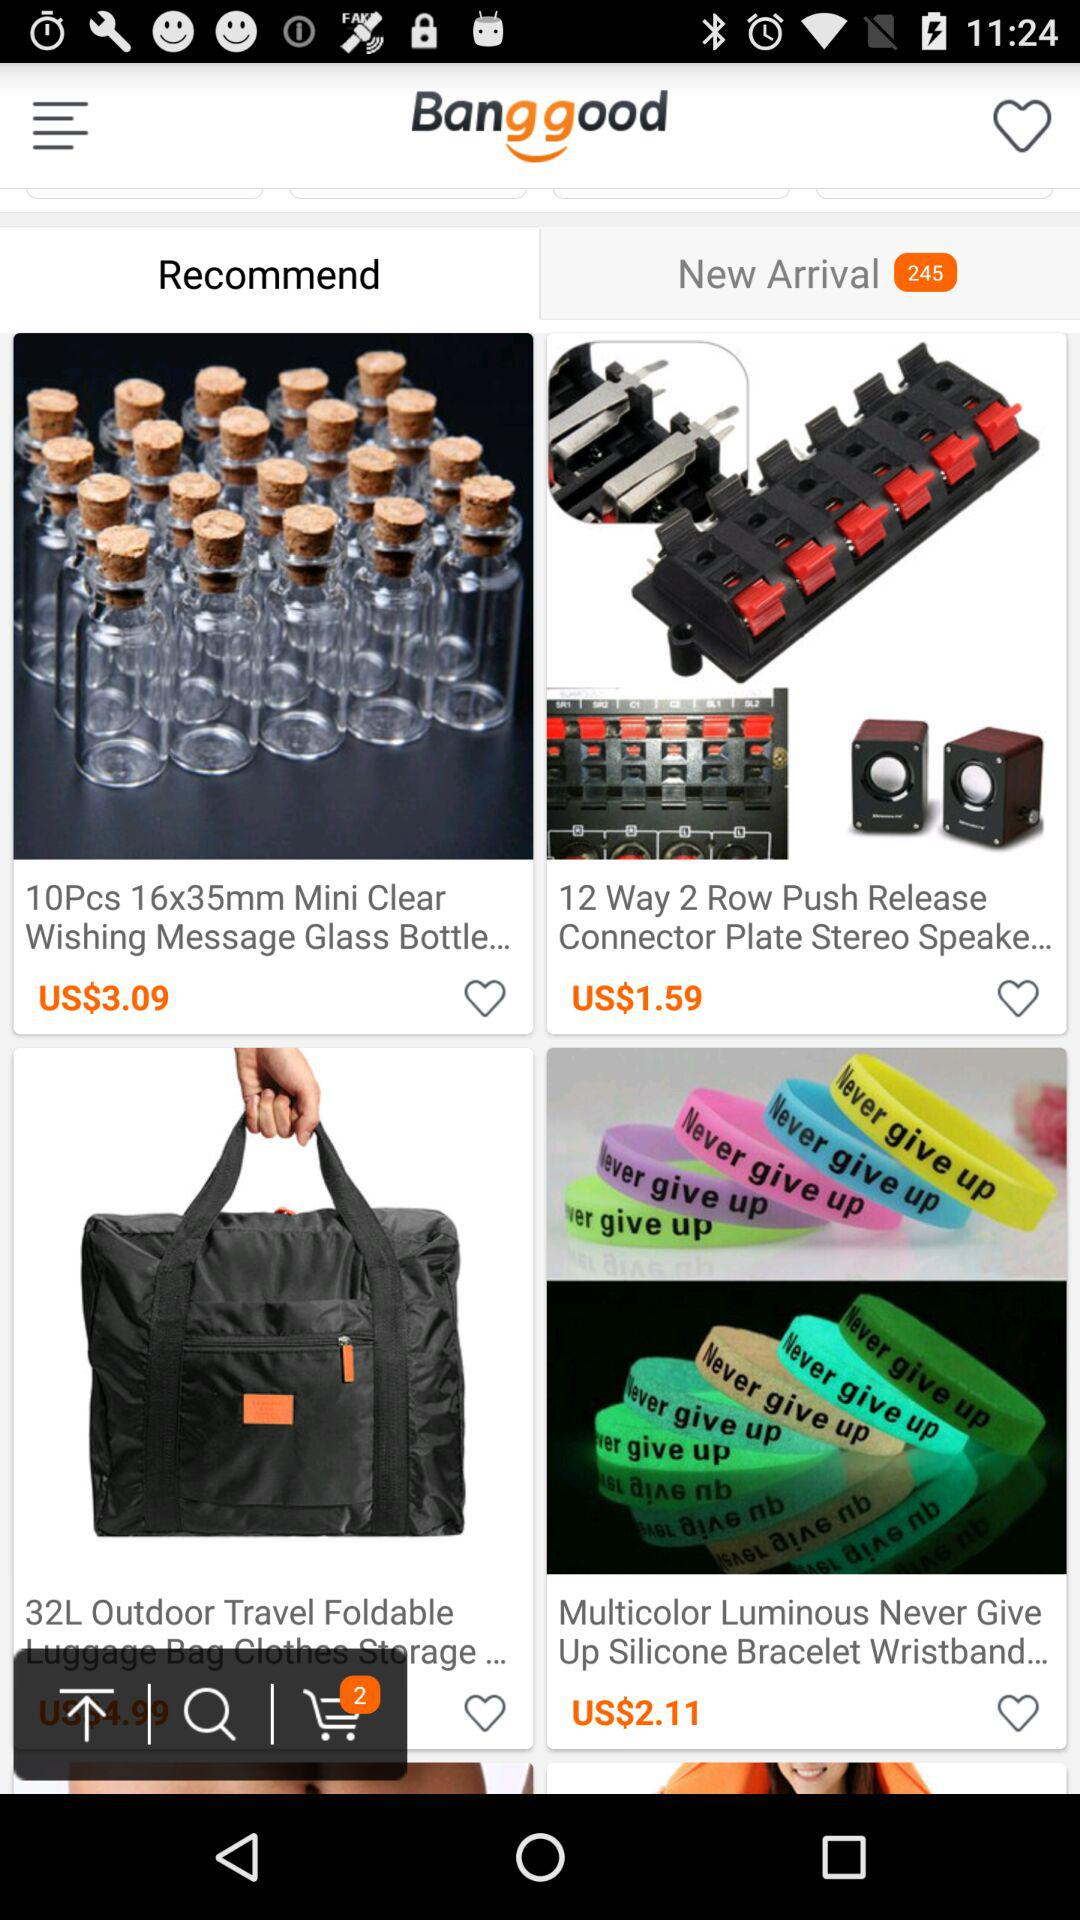How many items are in "New Arrival"? There are 245 items. 